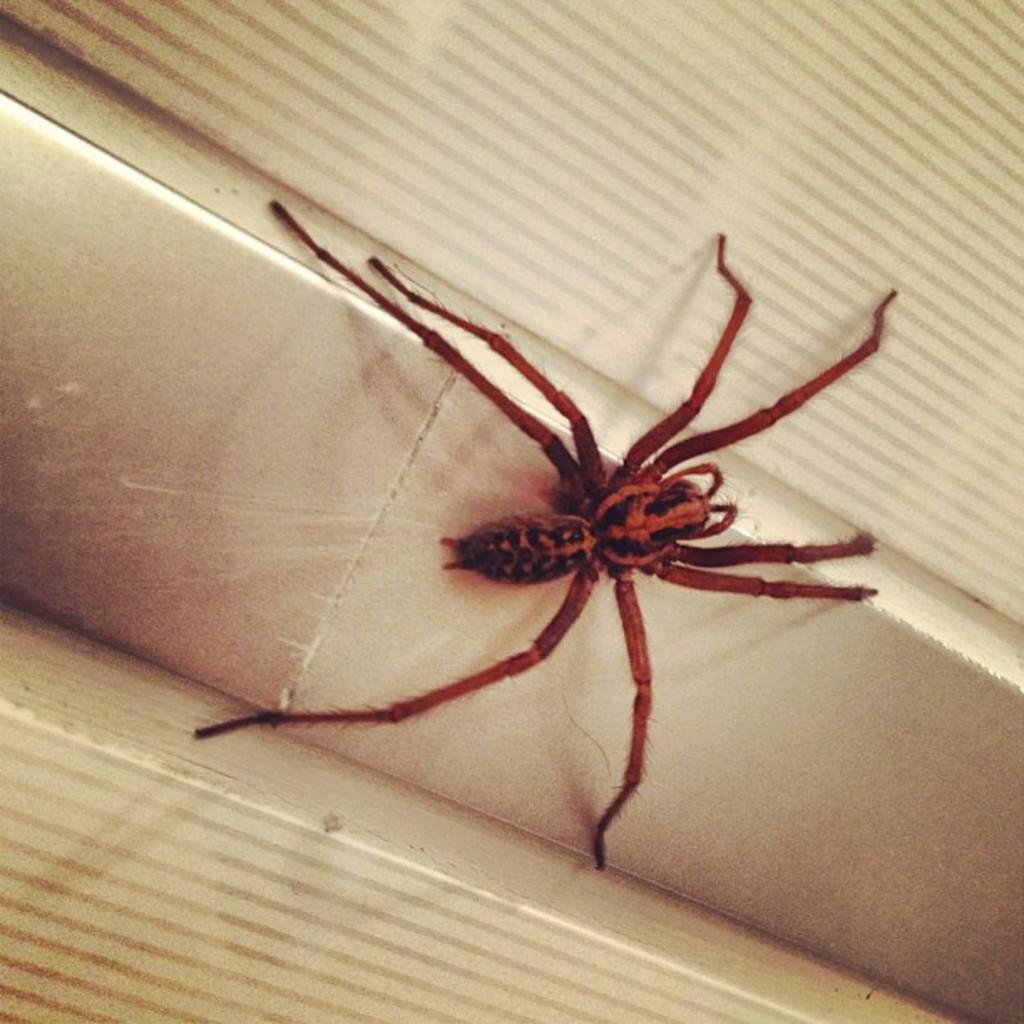What is present in the image? There is a spider in the image. Where is the spider located? The spider is on a wall. What type of brake can be seen on the spider in the image? There is no brake present on the spider in the image, as spiders do not have brakes. 